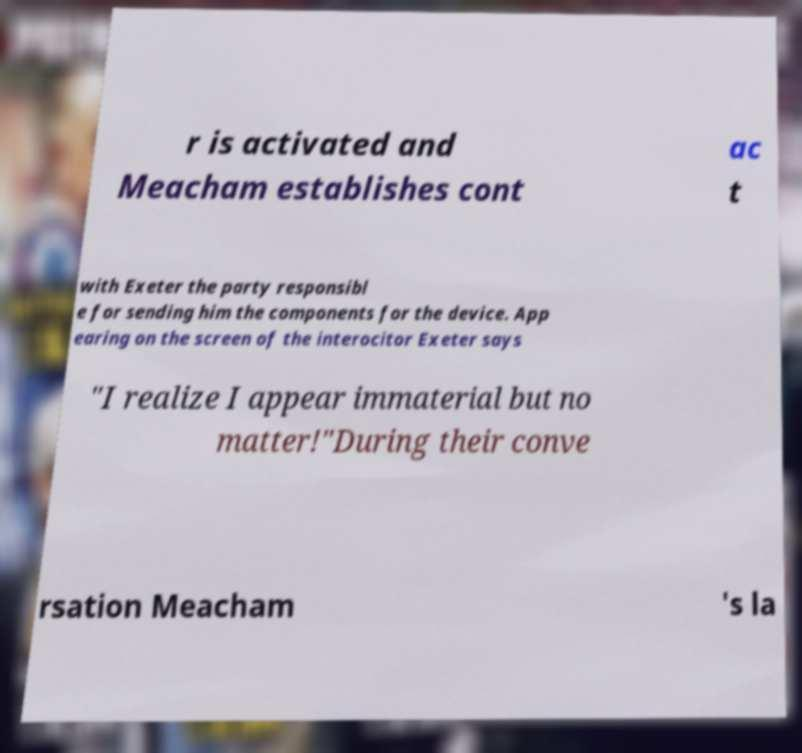Could you assist in decoding the text presented in this image and type it out clearly? r is activated and Meacham establishes cont ac t with Exeter the party responsibl e for sending him the components for the device. App earing on the screen of the interocitor Exeter says "I realize I appear immaterial but no matter!"During their conve rsation Meacham 's la 